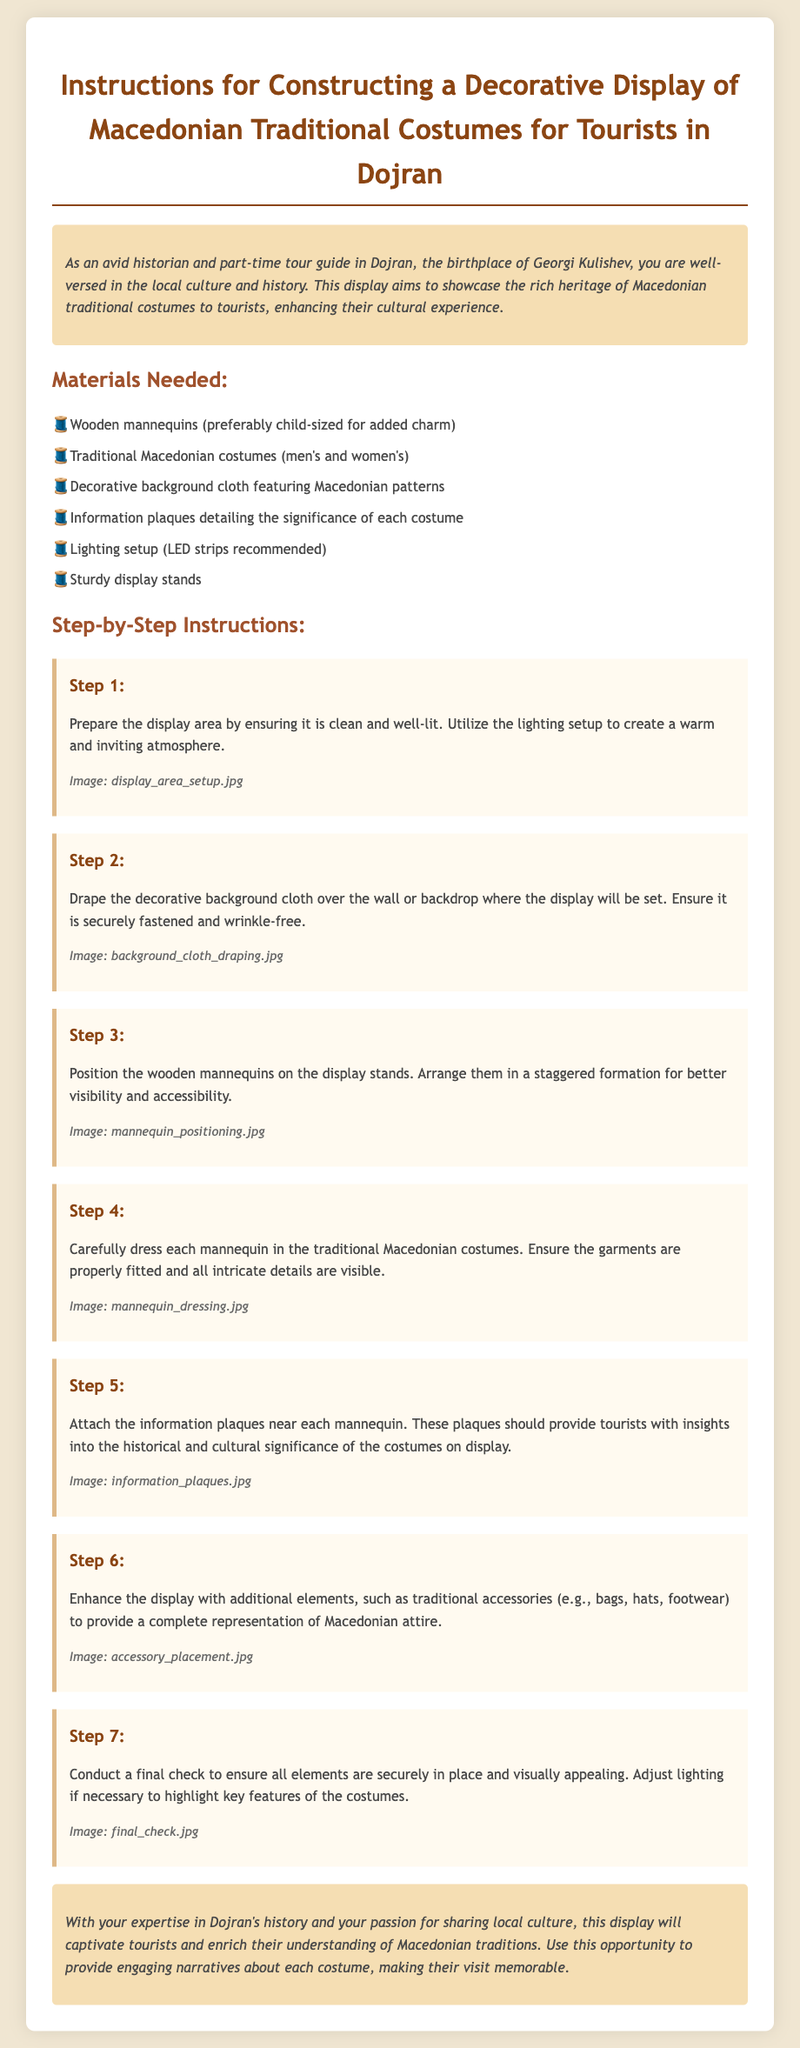What is the title of the document? The title of the document clearly states its purpose and is found at the top of the document.
Answer: Instructions for Constructing a Decorative Display of Macedonian Traditional Costumes for Tourists in Dojran How many materials are listed? The list of materials is found under the "Materials Needed" section which enumerates the items required for the display.
Answer: Six What is the first step in the instructions? The steps outline the order of tasks to be completed in setting up the display, starting with the preparation of the display area.
Answer: Prepare the display area What type of mannequins is suggested? The material list specifies the type of mannequins recommended for the display, which should enhance its charm.
Answer: Child-sized Which type of lighting is recommended? The step that discusses lighting mentions a specific type of lighting that is advised for use in the display.
Answer: LED strips What should be attached near each mannequin? The instructions highlight an important element that provides context about each costume for tourists, which should be placed close by.
Answer: Information plaques What is emphasized in the final check step? The last step of the instructions emphasizes the importance of ensuring the visual appeal and stability of all elements before the display is finished.
Answer: Visual appeal What additional elements can be included in the display? The step discussing enhancements to the display recommends additional items that can provide more context to Macedonian attire.
Answer: Traditional accessories 